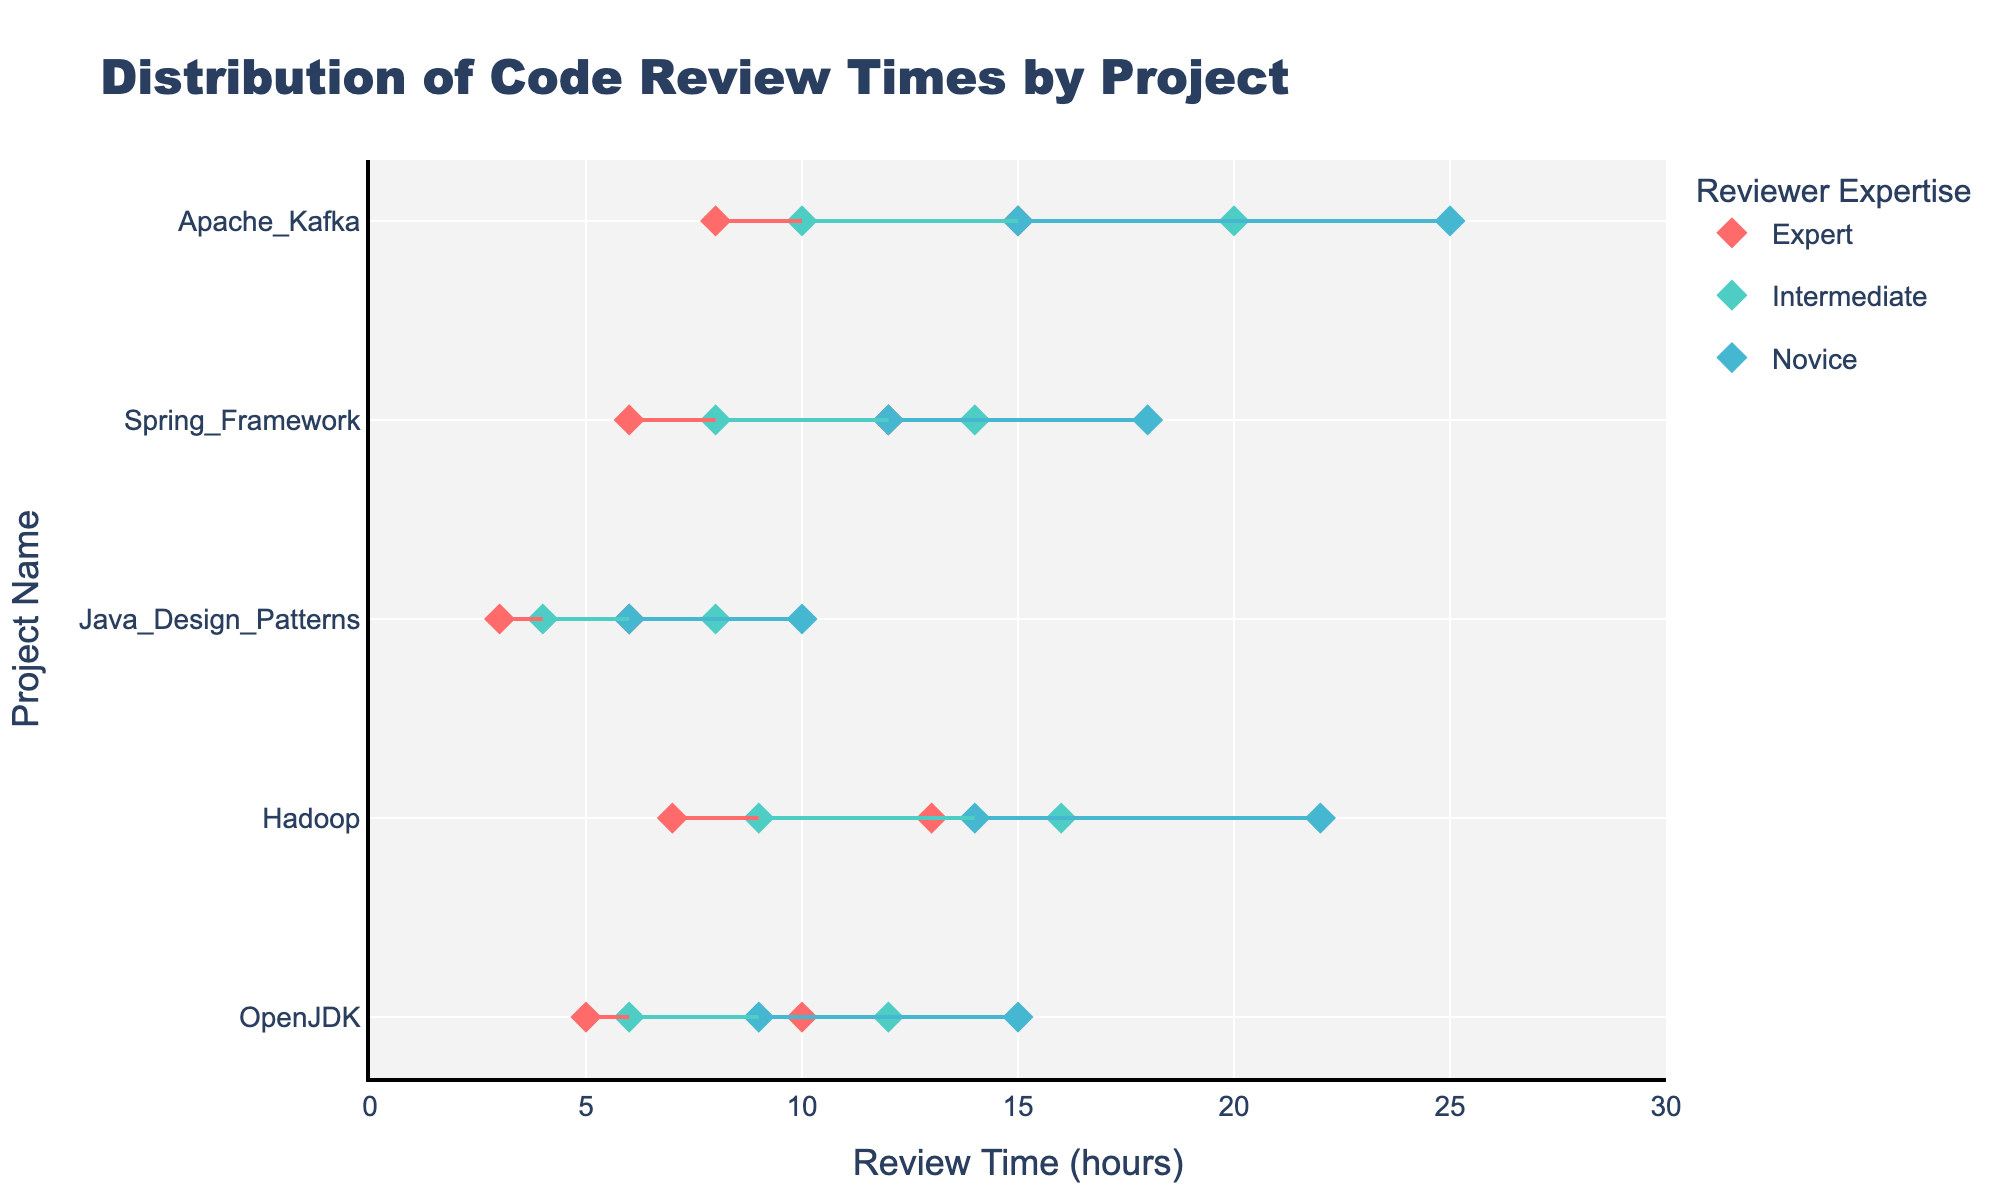What's the title of the figure? The title of the figure is shown at the top in large, bold text.
Answer: Distribution of Code Review Times by Project How many expertise levels are displayed in the legend? The legend groups are indicated by colors and labels on the right side of the plot.
Answer: 3 Which project has the widest review time range for novice reviewers? By examining the horizontal spans for novice reviewers (represented by a specific color and marker shape), we identify the widest range.
Answer: Apache Kafka What is the minimum review time for expert reviewers on the Spring Framework project? By locating the Spring Framework project on the y-axis and finding the minimum point on the plot for expert reviewers.
Answer: 6 hours Which project has the shortest maximum review time for expert reviewers? By comparing the maximum dots positioned on the x-axis for expert reviewers across all projects.
Answer: Java Design Patterns Is there any project where the maximum review time for novice reviewers is lower than the minimum review time for intermediate reviewers? By examining the minimum and maximum review times for novice and intermediate levels, we check if novice maximum is lower than intermediate minimum.
Answer: No How does the range of review times for intermediate reviewers on the Hadoop project compare to the range for experts on the same project? We look at the horizontal spans for intermediate and expert reviewers on Hadoop, then compare these lengths.
Answer: Intermediate: 9-16 hours, Expert: 7-13 hours (Intermediate range is wider) What is the difference in maximum review time between novice and expert reviewers for the OpenJDK project? Locate OpenJDK on the y-axis and find the maximum points for both novice and expert, then subtract.
Answer: 5 hours (15-10) Between large, medium, and small projects, which type sees the largest range for novice reviewers? By comparing the ranges (horizontal spans) of novice reviewers across project sizes as indicated in the plot.
Answer: Large For Apache Kafka, how much longer is the maximum review time for intermediate reviewers compared to expert reviewers? Find the maximum times for intermediate and expert levels on the x-axis for Apache Kafka, then subtract.
Answer: 5 hours (20-15) 